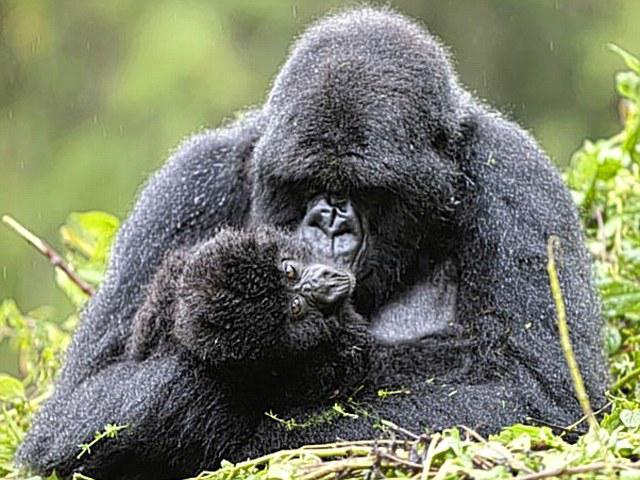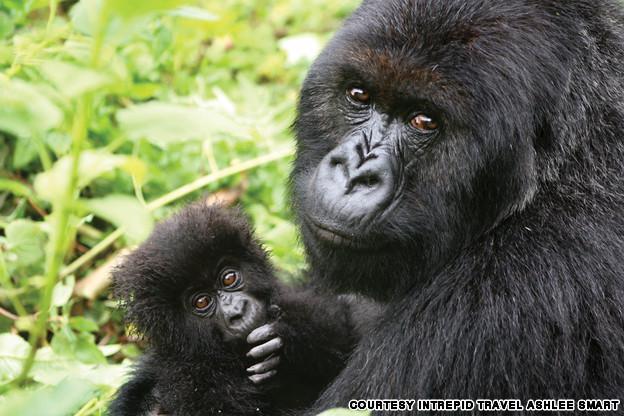The first image is the image on the left, the second image is the image on the right. Evaluate the accuracy of this statement regarding the images: "The combined images include exactly two baby gorillas with fuzzy black fur and at least one adult.". Is it true? Answer yes or no. Yes. The first image is the image on the left, the second image is the image on the right. Analyze the images presented: Is the assertion "the left and right image contains the same number of gorillas." valid? Answer yes or no. Yes. 